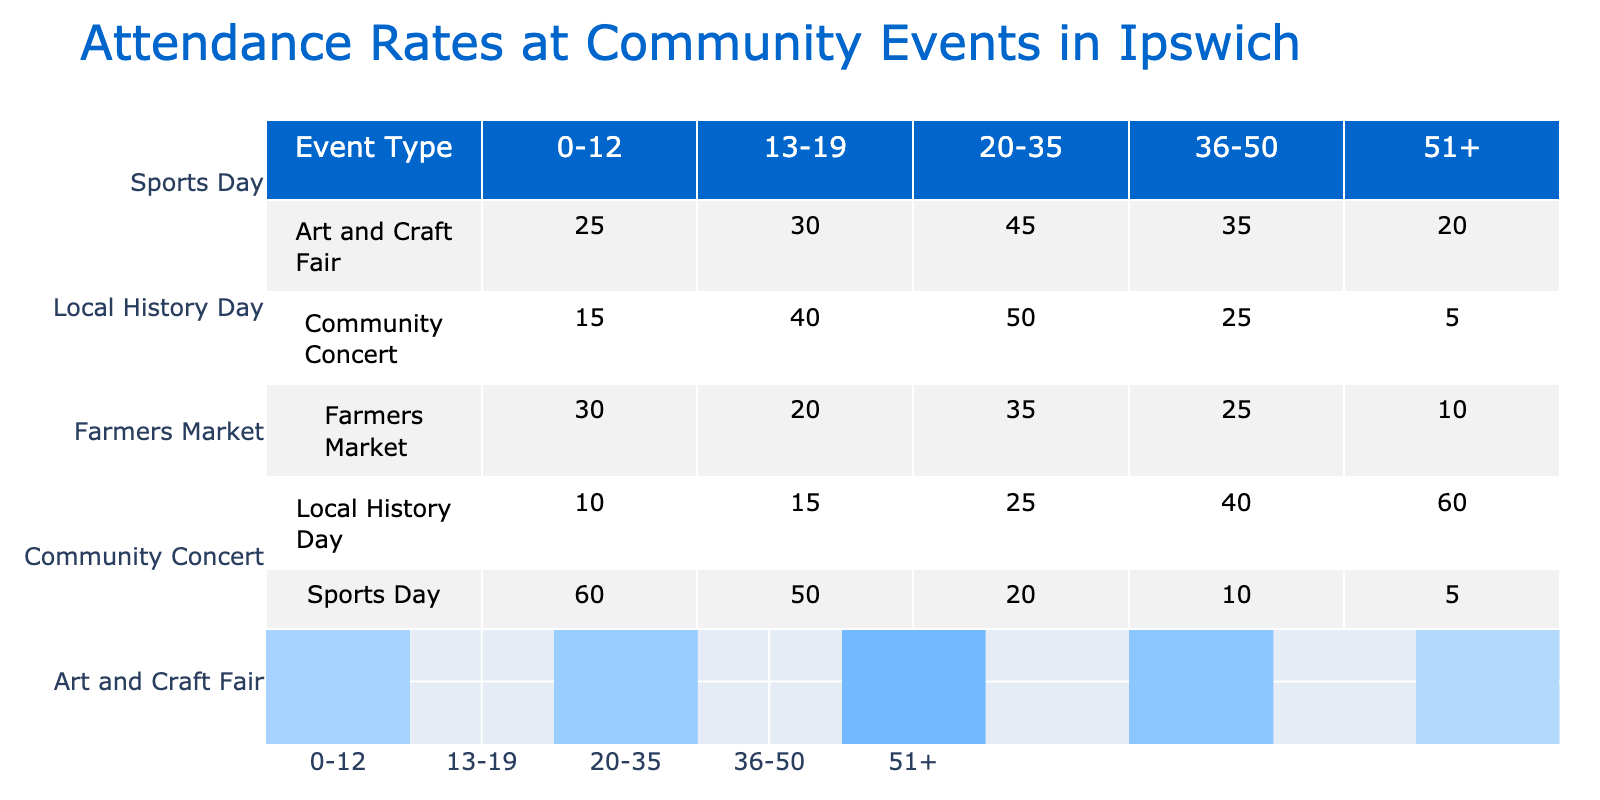What is the attendance rate for the 20-35 age group at the Farmers Market? Referring to the table, the attendance rate for the age group 20-35 at the Farmers Market is listed directly as 35%.
Answer: 35% Which event type had the highest attendance rate for the age group 0-12? Looking through the 0-12 age group attendance rates, Sports Day shows the highest rate at 60%, which is higher compared to Farmers Market (30%), Community Concert (15%), Art and Craft Fair (25%), and Local History Day (10%).
Answer: Sports Day What is the average attendance rate for the Community Concert across all age groups? To find the average, we sum the attendance rates for the Community Concert: (15 + 40 + 50 + 25 + 5) = 135. Then we divide by the number of age groups, which is 5: 135 / 5 = 27%.
Answer: 27% Is the attendance rate for the 51+ age group at the Local History Day higher than that for Art and Craft Fair? The attendance rate for the 51+ age group at Local History Day is 60%, while at Art and Craft Fair it is 20%. Since 60% is greater than 20%, the statement is true.
Answer: Yes Which age group had the lowest attendance rate for the Sports Day event? For Sports Day, the attendance rates are 60% for 0-12, 50% for 13-19, 20% for 20-35, 10% for 36-50, and 5% for 51+. Comparing these, the lowest rate is 5% for the 51+ age group.
Answer: 51+ What is the difference in attendance rates between the 20-35 age group for Community Concert and for Art and Craft Fair? For Community Concert, the attendance rate is 50%, and for Art and Craft Fair it is 45%. The difference is calculated as 50% - 45% = 5%.
Answer: 5% Can you confirm if all events had at least one age group with an attendance rate below 15%? Checking the attendance rates, we find that the Community Concert has 5% for the 51+ age group, which means it does meet the condition. All events have at least one age group with attendance below 15%.
Answer: Yes What is the total attendance rate for the age group 36-50 across all event types? Adding the attendance rates for the 36-50 age group: 25% (Farmers Market) + 25% (Community Concert) + 35% (Art and Craft Fair) + 10% (Sports Day) + 40% (Local History Day) = 125%.
Answer: 125% 